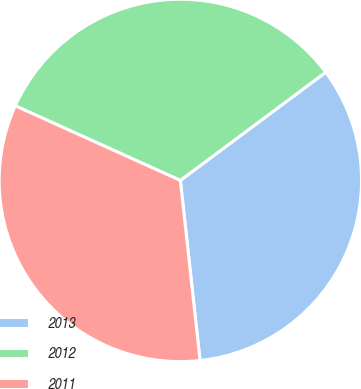<chart> <loc_0><loc_0><loc_500><loc_500><pie_chart><fcel>2013<fcel>2012<fcel>2011<nl><fcel>33.45%<fcel>33.06%<fcel>33.49%<nl></chart> 